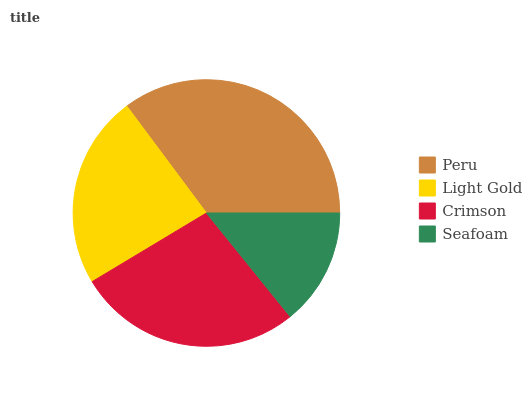Is Seafoam the minimum?
Answer yes or no. Yes. Is Peru the maximum?
Answer yes or no. Yes. Is Light Gold the minimum?
Answer yes or no. No. Is Light Gold the maximum?
Answer yes or no. No. Is Peru greater than Light Gold?
Answer yes or no. Yes. Is Light Gold less than Peru?
Answer yes or no. Yes. Is Light Gold greater than Peru?
Answer yes or no. No. Is Peru less than Light Gold?
Answer yes or no. No. Is Crimson the high median?
Answer yes or no. Yes. Is Light Gold the low median?
Answer yes or no. Yes. Is Light Gold the high median?
Answer yes or no. No. Is Seafoam the low median?
Answer yes or no. No. 